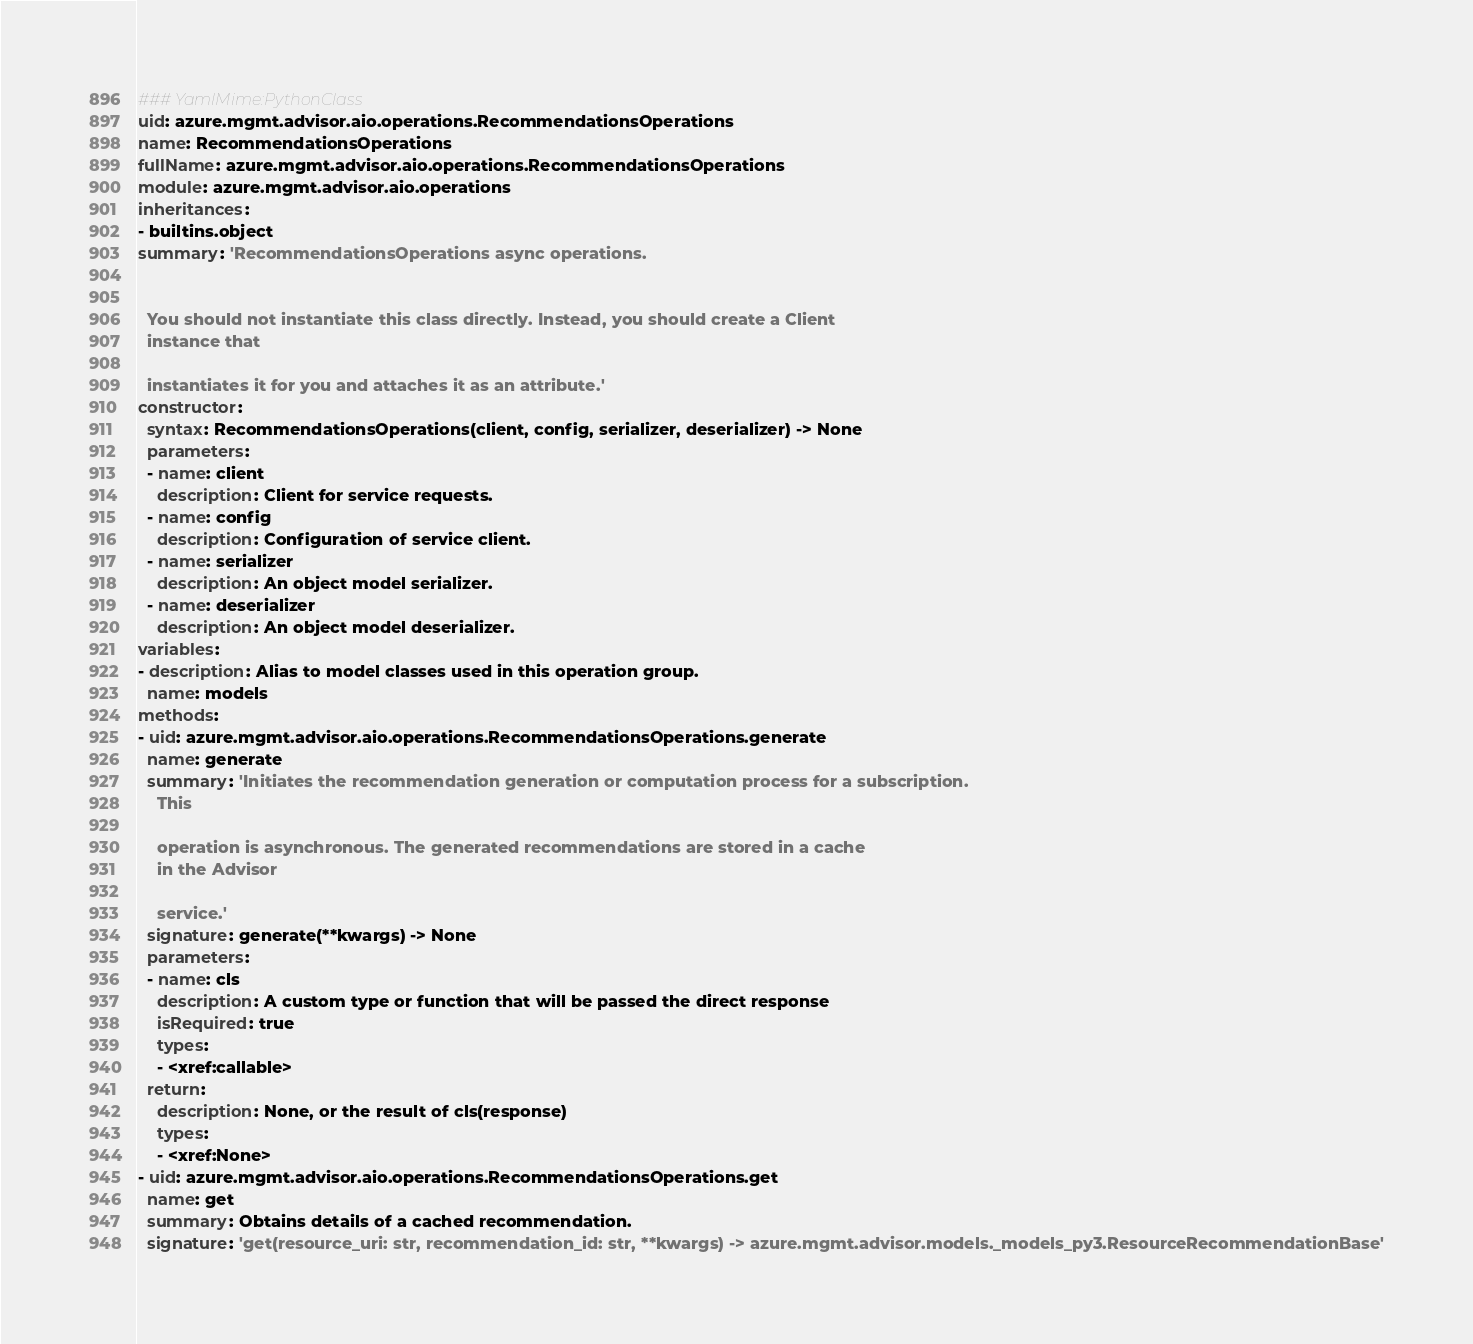Convert code to text. <code><loc_0><loc_0><loc_500><loc_500><_YAML_>### YamlMime:PythonClass
uid: azure.mgmt.advisor.aio.operations.RecommendationsOperations
name: RecommendationsOperations
fullName: azure.mgmt.advisor.aio.operations.RecommendationsOperations
module: azure.mgmt.advisor.aio.operations
inheritances:
- builtins.object
summary: 'RecommendationsOperations async operations.


  You should not instantiate this class directly. Instead, you should create a Client
  instance that

  instantiates it for you and attaches it as an attribute.'
constructor:
  syntax: RecommendationsOperations(client, config, serializer, deserializer) -> None
  parameters:
  - name: client
    description: Client for service requests.
  - name: config
    description: Configuration of service client.
  - name: serializer
    description: An object model serializer.
  - name: deserializer
    description: An object model deserializer.
variables:
- description: Alias to model classes used in this operation group.
  name: models
methods:
- uid: azure.mgmt.advisor.aio.operations.RecommendationsOperations.generate
  name: generate
  summary: 'Initiates the recommendation generation or computation process for a subscription.
    This

    operation is asynchronous. The generated recommendations are stored in a cache
    in the Advisor

    service.'
  signature: generate(**kwargs) -> None
  parameters:
  - name: cls
    description: A custom type or function that will be passed the direct response
    isRequired: true
    types:
    - <xref:callable>
  return:
    description: None, or the result of cls(response)
    types:
    - <xref:None>
- uid: azure.mgmt.advisor.aio.operations.RecommendationsOperations.get
  name: get
  summary: Obtains details of a cached recommendation.
  signature: 'get(resource_uri: str, recommendation_id: str, **kwargs) -> azure.mgmt.advisor.models._models_py3.ResourceRecommendationBase'</code> 